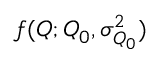<formula> <loc_0><loc_0><loc_500><loc_500>f ( Q ; Q _ { 0 } , \sigma _ { Q _ { 0 } } ^ { 2 } )</formula> 